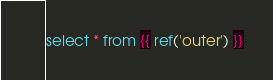<code> <loc_0><loc_0><loc_500><loc_500><_SQL_>select * from {{ ref('outer') }}
</code> 